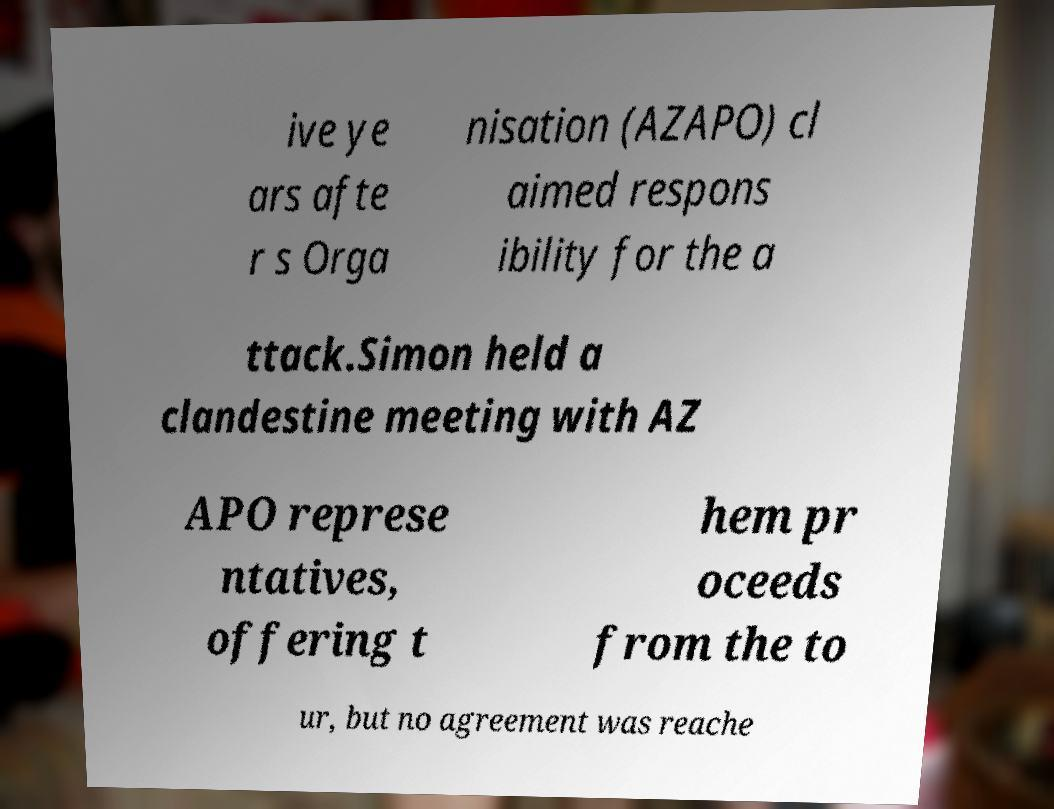Could you extract and type out the text from this image? ive ye ars afte r s Orga nisation (AZAPO) cl aimed respons ibility for the a ttack.Simon held a clandestine meeting with AZ APO represe ntatives, offering t hem pr oceeds from the to ur, but no agreement was reache 